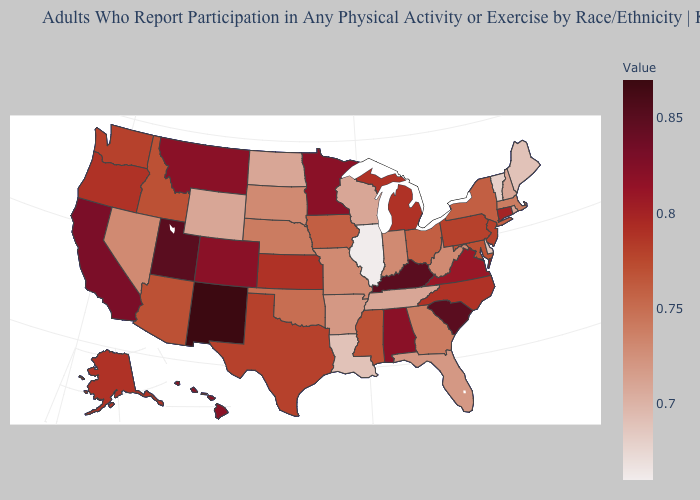Which states have the lowest value in the Northeast?
Write a very short answer. Vermont. Does the map have missing data?
Write a very short answer. No. Among the states that border Texas , does Louisiana have the lowest value?
Keep it brief. Yes. Among the states that border West Virginia , does Virginia have the lowest value?
Concise answer only. No. Does New York have the lowest value in the USA?
Be succinct. No. Does Montana have a lower value than Florida?
Short answer required. No. 